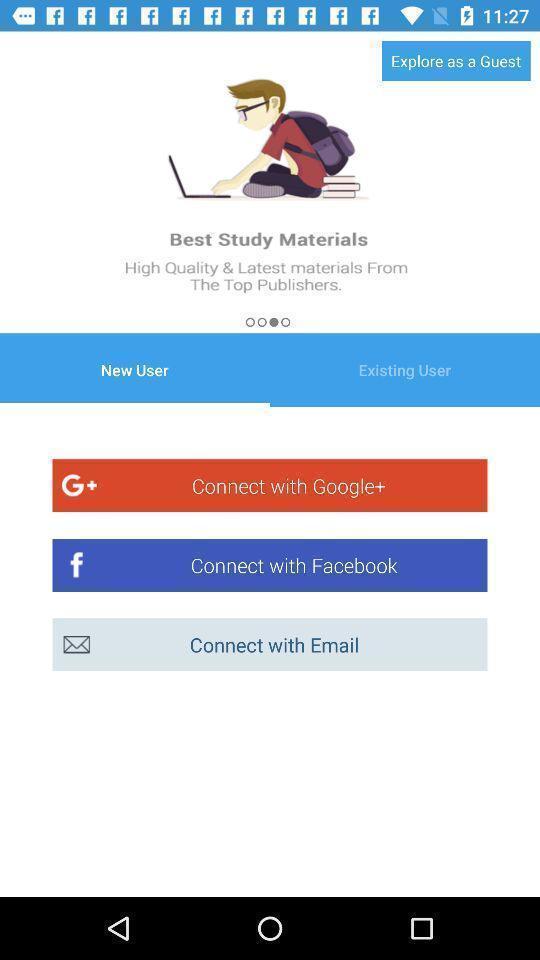Explain what's happening in this screen capture. Welcome page for an app. 